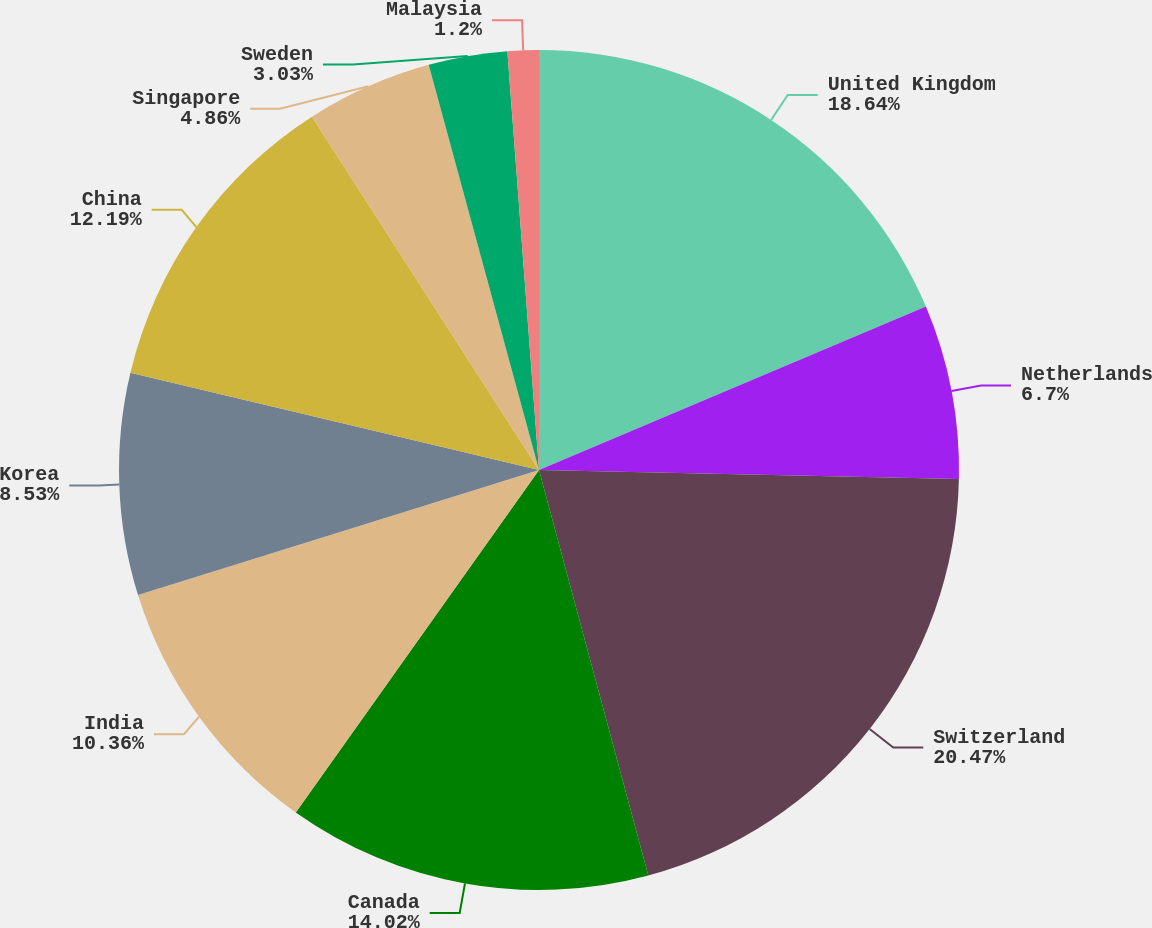Convert chart. <chart><loc_0><loc_0><loc_500><loc_500><pie_chart><fcel>United Kingdom<fcel>Netherlands<fcel>Switzerland<fcel>Canada<fcel>India<fcel>Korea<fcel>China<fcel>Singapore<fcel>Sweden<fcel>Malaysia<nl><fcel>18.64%<fcel>6.7%<fcel>20.47%<fcel>14.02%<fcel>10.36%<fcel>8.53%<fcel>12.19%<fcel>4.86%<fcel>3.03%<fcel>1.2%<nl></chart> 